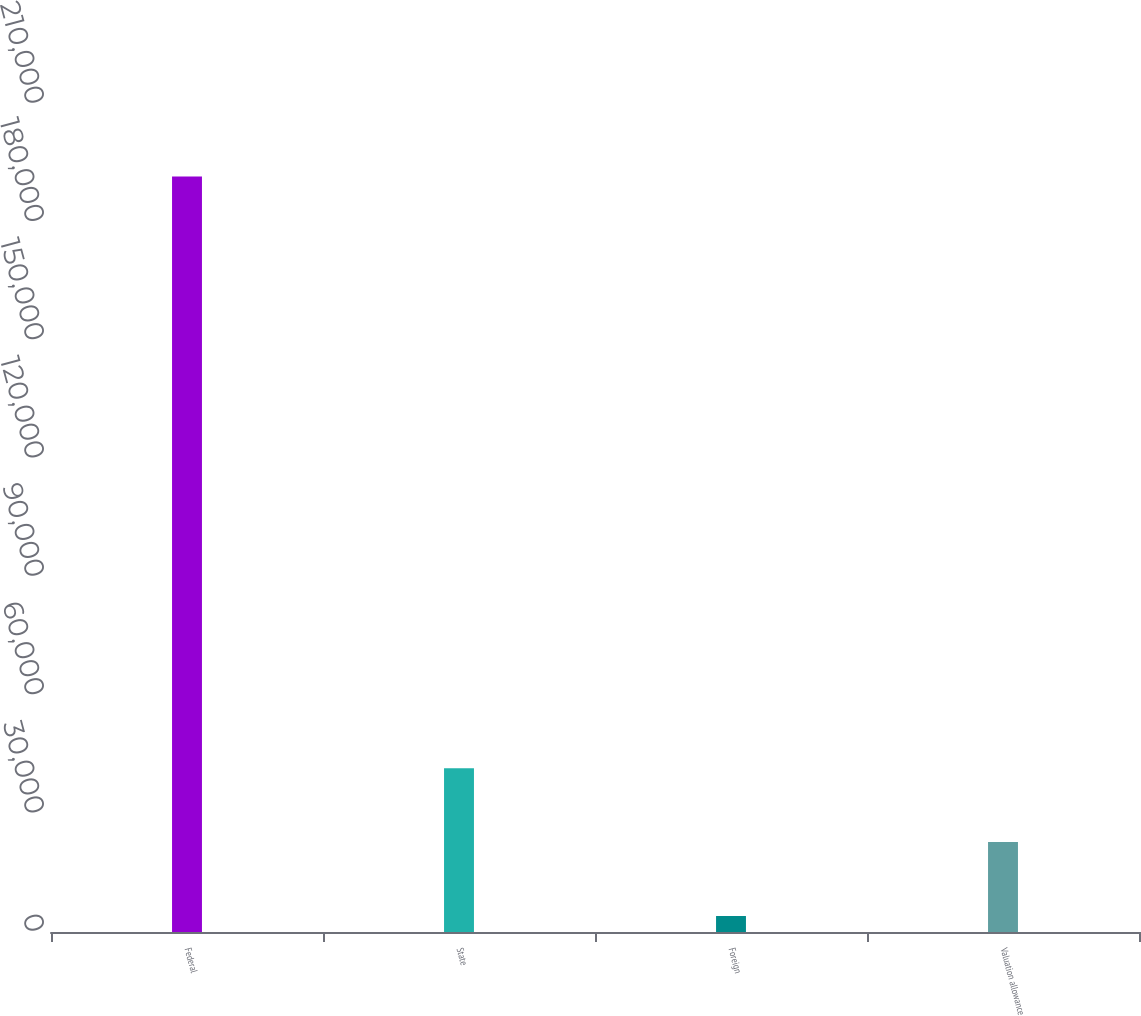Convert chart to OTSL. <chart><loc_0><loc_0><loc_500><loc_500><bar_chart><fcel>Federal<fcel>State<fcel>Foreign<fcel>Valuation allowance<nl><fcel>191596<fcel>41560.8<fcel>4052<fcel>22806.4<nl></chart> 